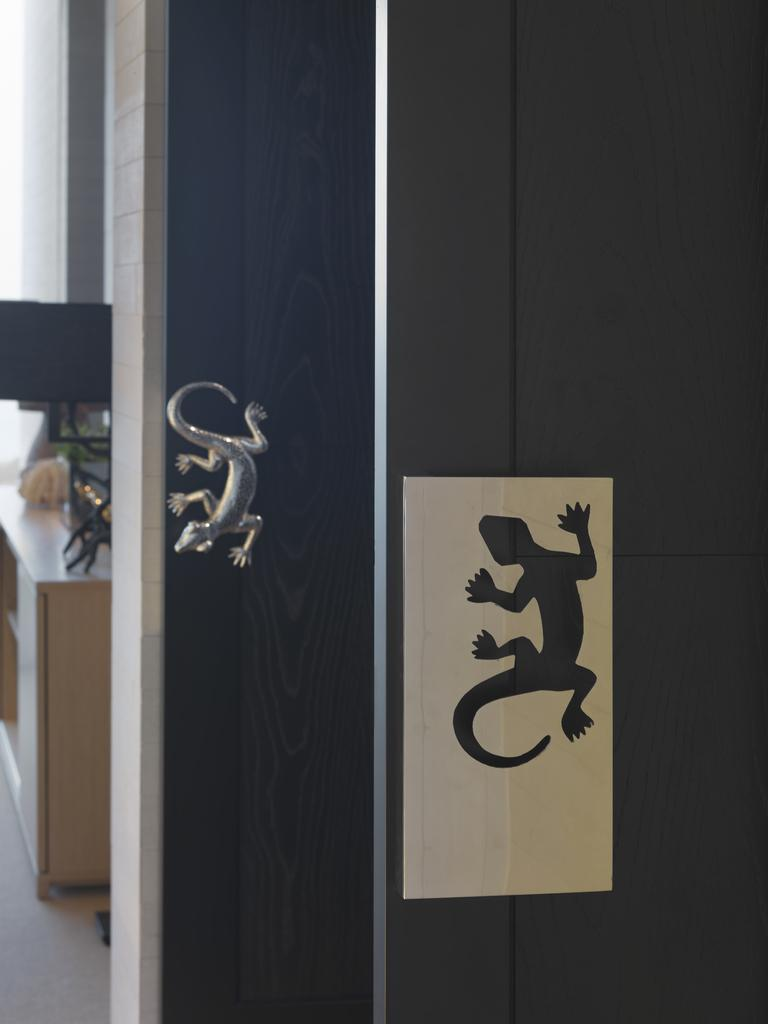What type of animal is depicted on the wall in the image? The wall features a lizard sticker and a metal lizard idol. Can you describe the objects on the left side of the image? There is a table with some things on the left side of the image. What type of nerve can be seen in the image? There is no nerve present in the image. Is there a veil covering the lizard idol in the image? No, there is no veil covering the lizard idol in the image. 